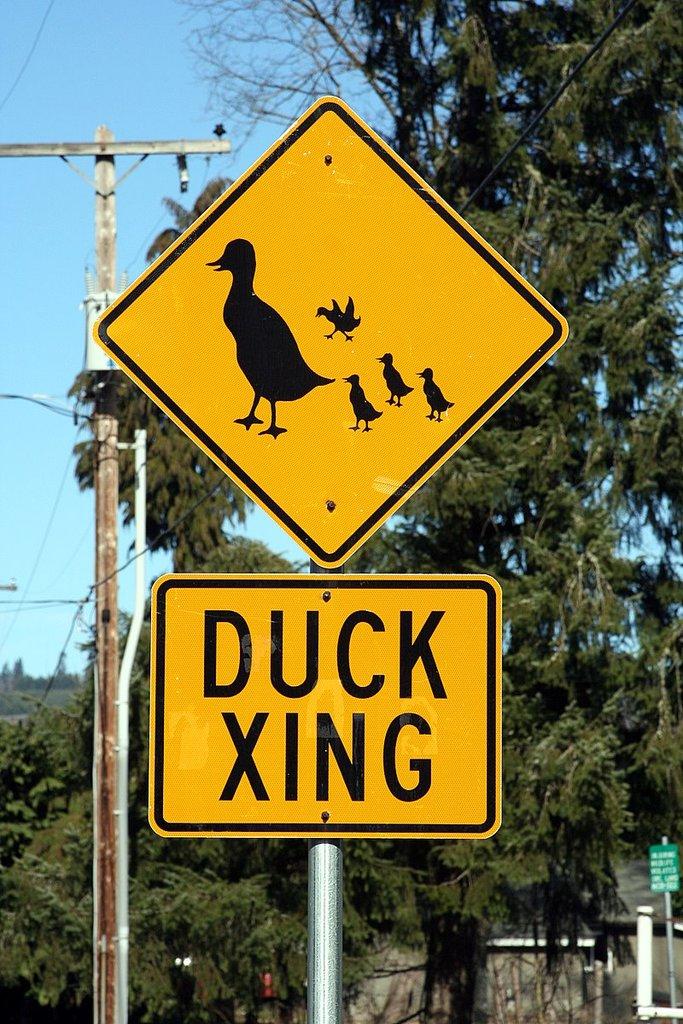What animal crosses here?
Make the answer very short. Duck. 